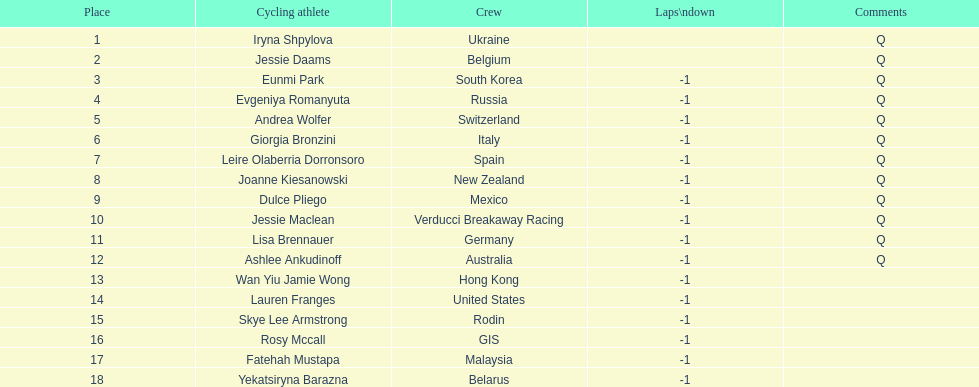How many consecutive notes are there? 12. 